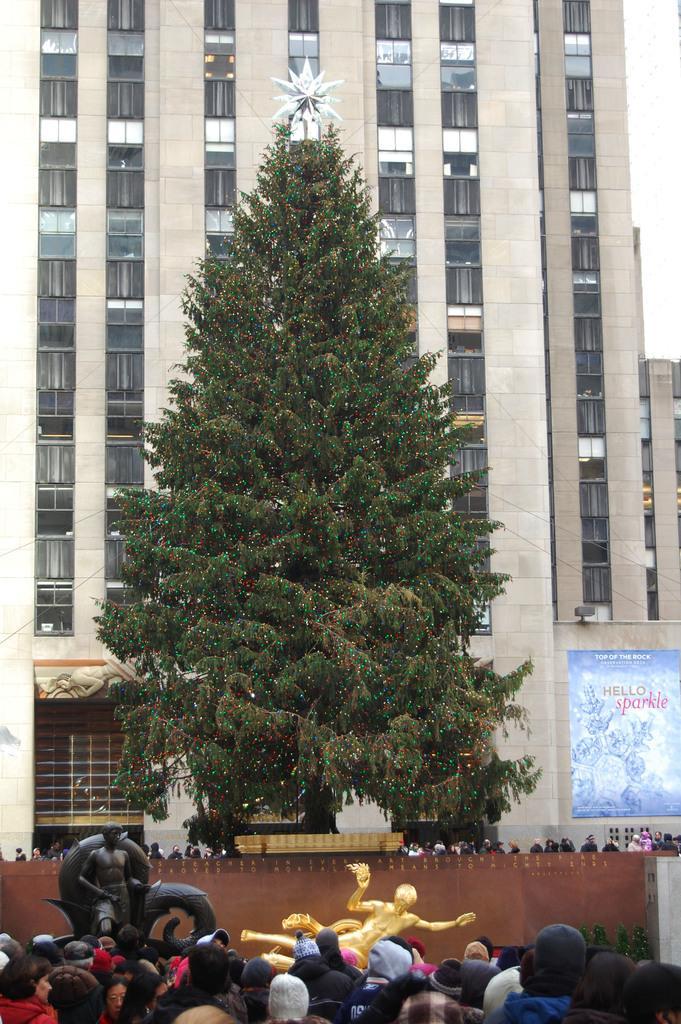Can you describe this image briefly? In this image in the center there is one tree, and at the bottom there are some people and some statues and a wall. On the right side there is one board, and in the background there is a building. 